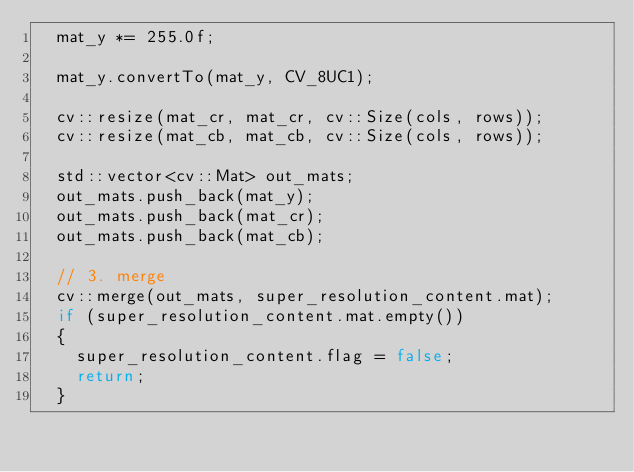Convert code to text. <code><loc_0><loc_0><loc_500><loc_500><_C++_>  mat_y *= 255.0f;

  mat_y.convertTo(mat_y, CV_8UC1);

  cv::resize(mat_cr, mat_cr, cv::Size(cols, rows));
  cv::resize(mat_cb, mat_cb, cv::Size(cols, rows));

  std::vector<cv::Mat> out_mats;
  out_mats.push_back(mat_y);
  out_mats.push_back(mat_cr);
  out_mats.push_back(mat_cb);

  // 3. merge
  cv::merge(out_mats, super_resolution_content.mat);
  if (super_resolution_content.mat.empty())
  {
    super_resolution_content.flag = false;
    return;
  }</code> 